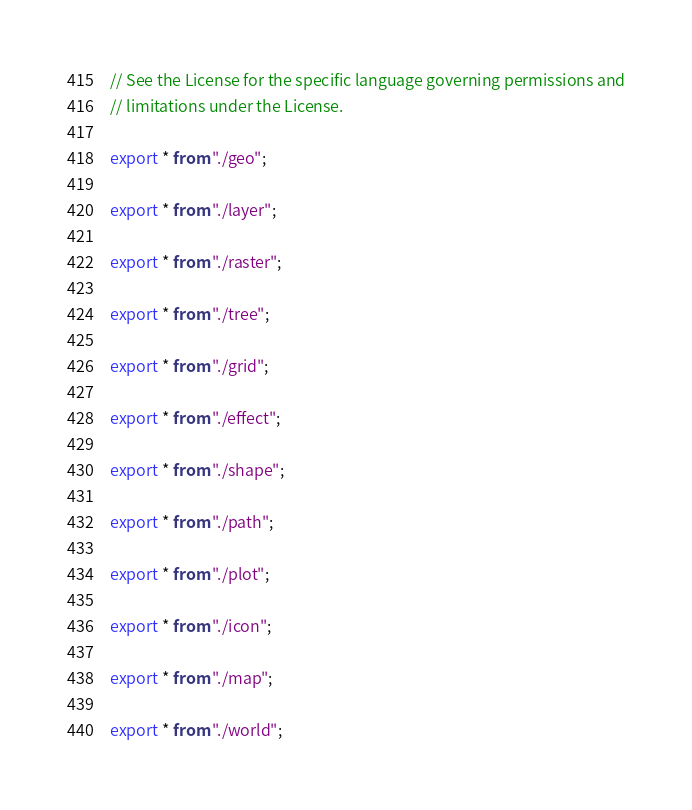Convert code to text. <code><loc_0><loc_0><loc_500><loc_500><_TypeScript_>// See the License for the specific language governing permissions and
// limitations under the License.

export * from "./geo";

export * from "./layer";

export * from "./raster";

export * from "./tree";

export * from "./grid";

export * from "./effect";

export * from "./shape";

export * from "./path";

export * from "./plot";

export * from "./icon";

export * from "./map";

export * from "./world";
</code> 